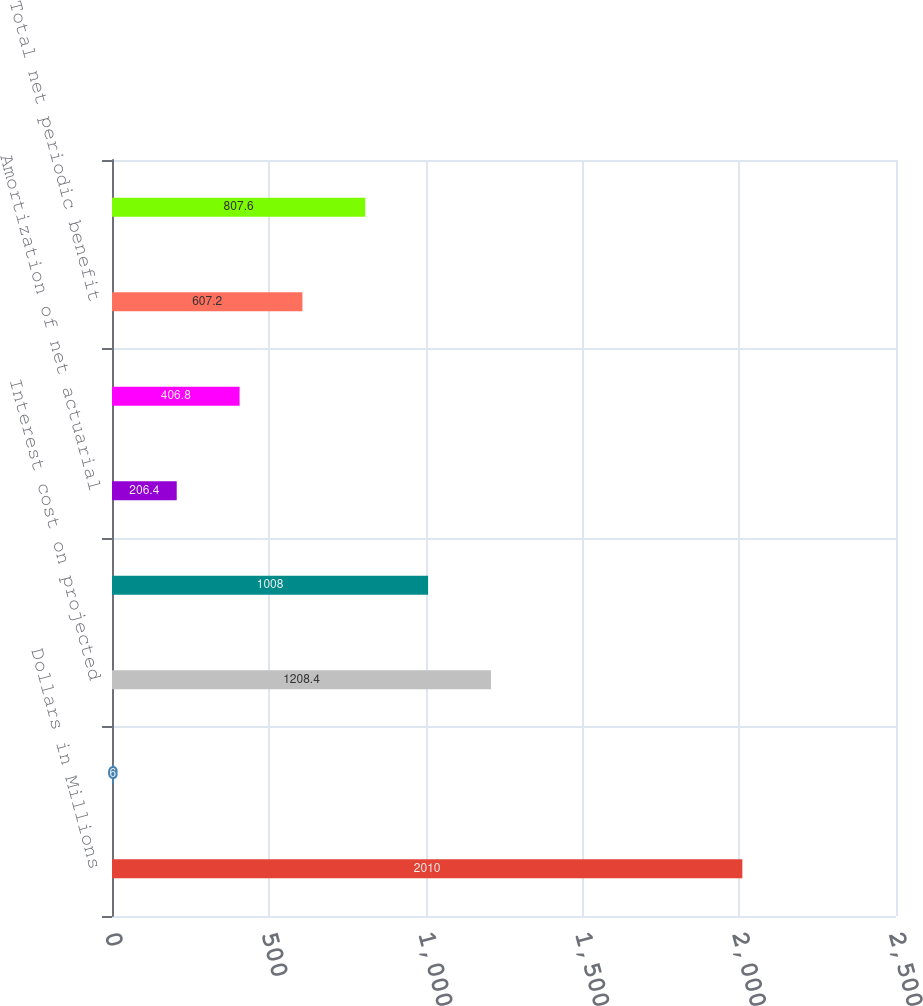Convert chart to OTSL. <chart><loc_0><loc_0><loc_500><loc_500><bar_chart><fcel>Dollars in Millions<fcel>Service cost - benefits earned<fcel>Interest cost on projected<fcel>Expected return on plan assets<fcel>Amortization of net actuarial<fcel>Net periodic benefit cost<fcel>Total net periodic benefit<fcel>Continuing operations<nl><fcel>2010<fcel>6<fcel>1208.4<fcel>1008<fcel>206.4<fcel>406.8<fcel>607.2<fcel>807.6<nl></chart> 